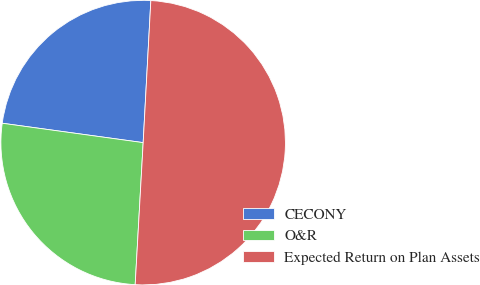Convert chart to OTSL. <chart><loc_0><loc_0><loc_500><loc_500><pie_chart><fcel>CECONY<fcel>O&R<fcel>Expected Return on Plan Assets<nl><fcel>23.68%<fcel>26.28%<fcel>50.03%<nl></chart> 